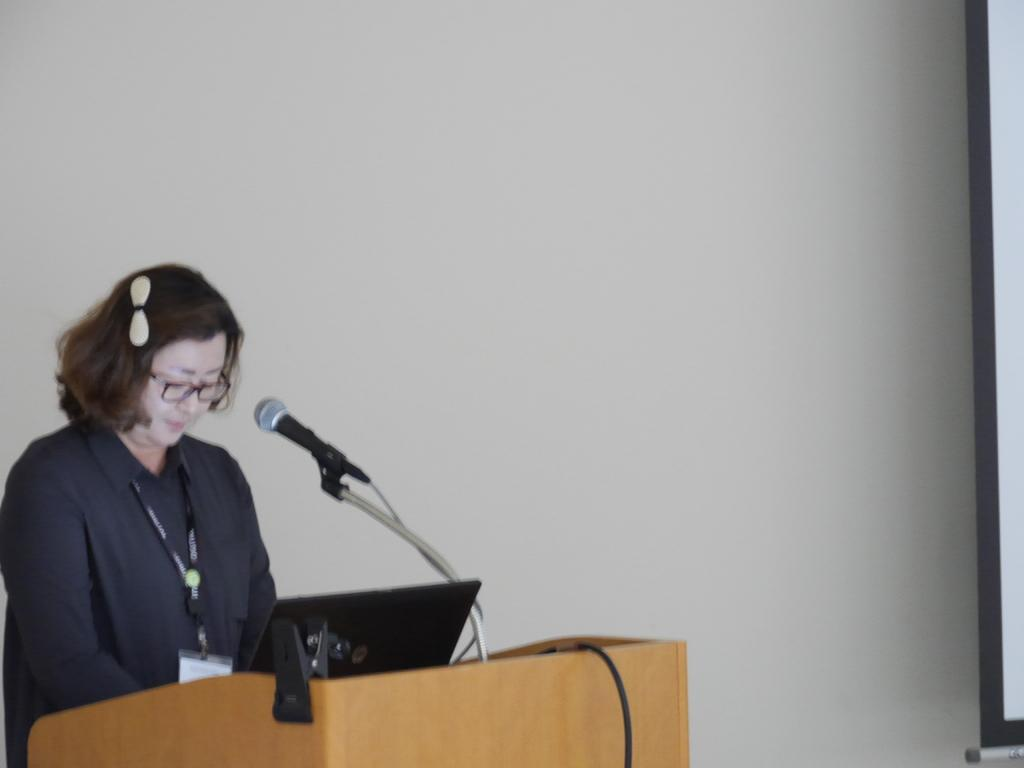What is the person in the image doing? The person is standing in front of the podium. What can be seen on the podium? There is a laptop, a mic, and a stand on the podium. What is visible on the projection-screen in the background? The content on the projection-screen cannot be determined from the image. What is the color of the wall in the background? The wall in the background is white. How much money is being exchanged between the person and the snake in the image? There is no snake or money exchange present in the image. What is the person's chin doing in the image? The person's chin cannot be determined from the image, as it only shows the person from the chest up. 